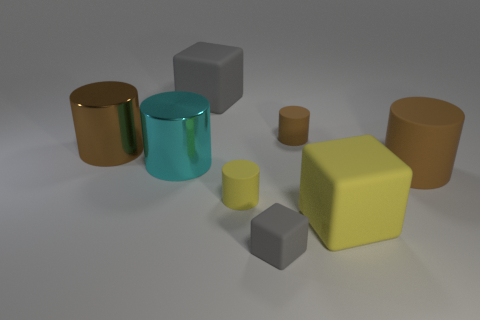Subtract all green cubes. How many brown cylinders are left? 3 Subtract 2 cylinders. How many cylinders are left? 3 Subtract all tiny brown cylinders. How many cylinders are left? 4 Subtract all yellow cylinders. How many cylinders are left? 4 Subtract all purple cylinders. Subtract all gray spheres. How many cylinders are left? 5 Add 1 cyan things. How many objects exist? 9 Subtract all cylinders. How many objects are left? 3 Subtract 0 cyan cubes. How many objects are left? 8 Subtract all tiny things. Subtract all tiny yellow cylinders. How many objects are left? 4 Add 7 tiny yellow things. How many tiny yellow things are left? 8 